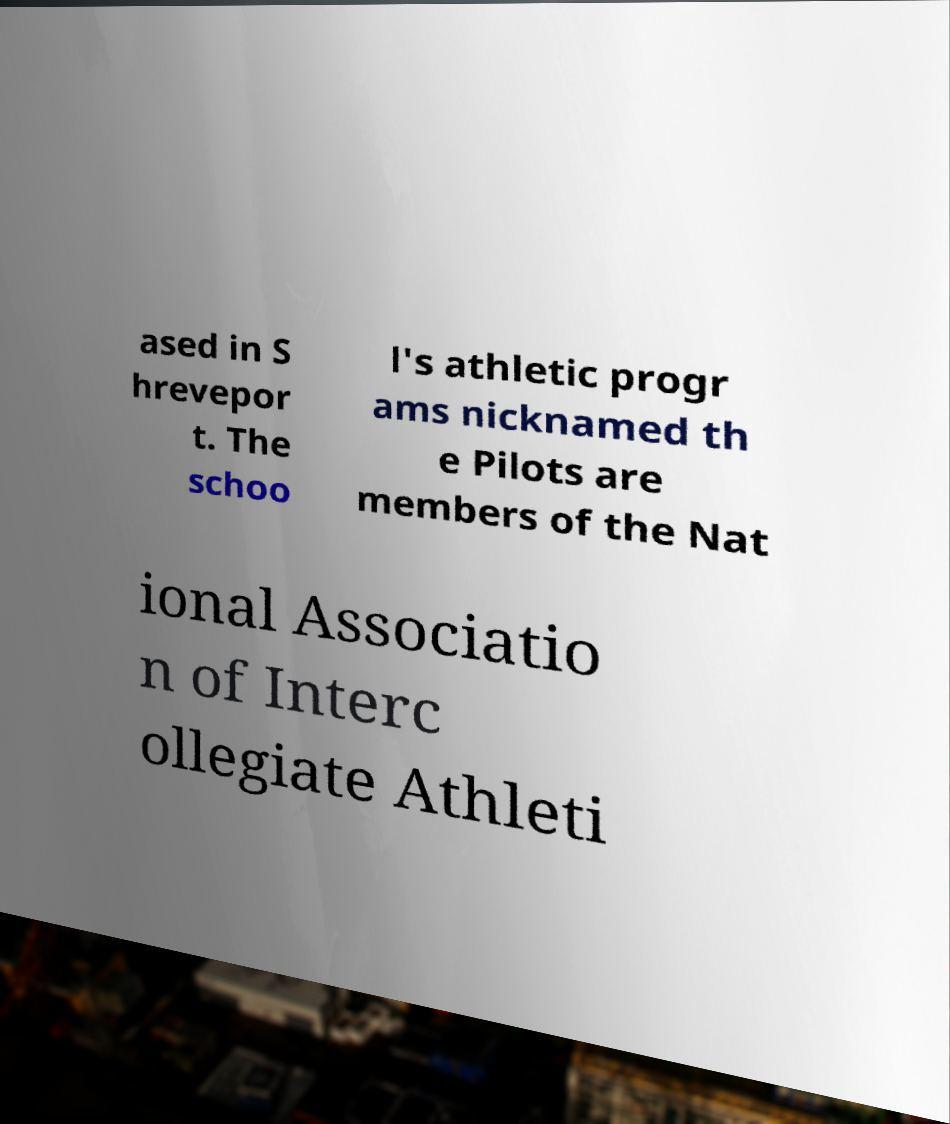Could you extract and type out the text from this image? ased in S hrevepor t. The schoo l's athletic progr ams nicknamed th e Pilots are members of the Nat ional Associatio n of Interc ollegiate Athleti 